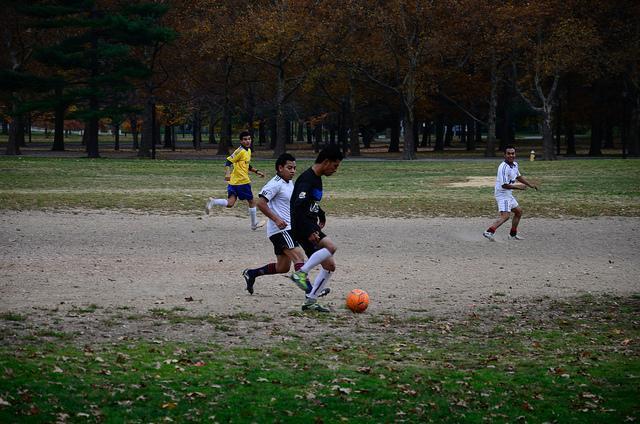What are the boys doing with the orange ball?
Select the accurate response from the four choices given to answer the question.
Options: Painting it, dribbling it, throwing it, kicking it. Kicking it. 